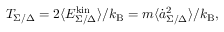<formula> <loc_0><loc_0><loc_500><loc_500>T _ { \Sigma / \Delta } = 2 \langle E _ { \Sigma / \Delta } ^ { k i n } \rangle / k _ { B } = m \langle \dot { a } _ { \Sigma / \Delta } ^ { 2 } \rangle / k _ { B } ,</formula> 